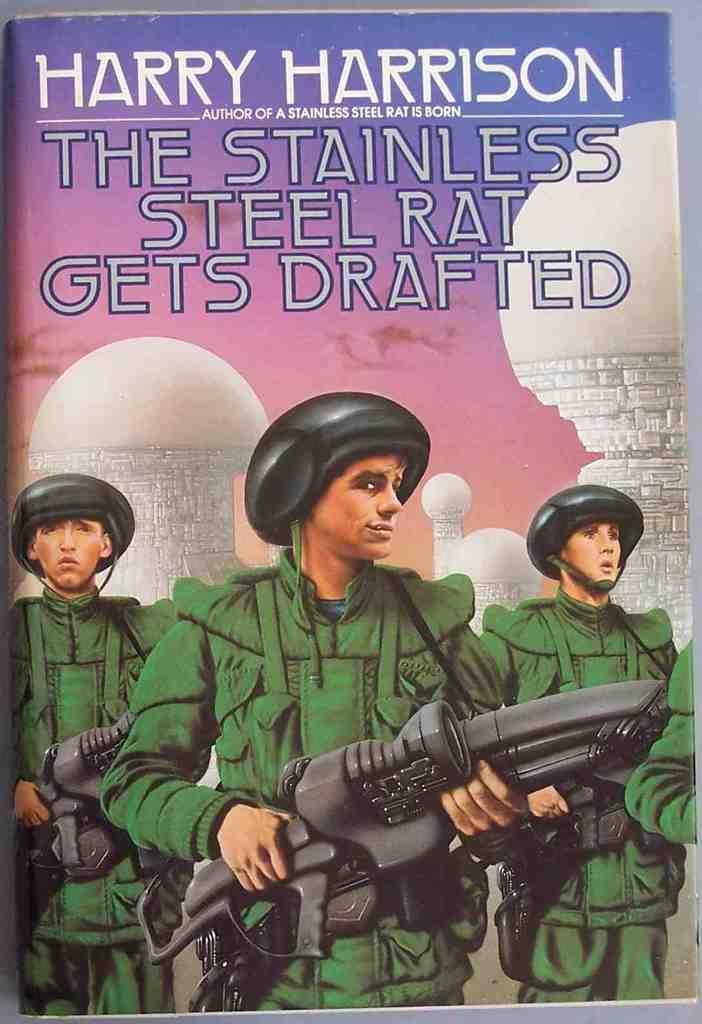Provide a one-sentence caption for the provided image. The army book is written by Harry Harrison. 